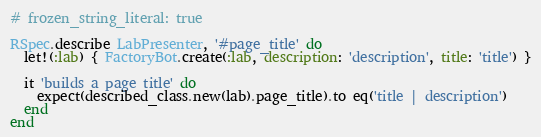<code> <loc_0><loc_0><loc_500><loc_500><_Ruby_># frozen_string_literal: true

RSpec.describe LabPresenter, '#page_title' do
  let!(:lab) { FactoryBot.create(:lab, description: 'description', title: 'title') }

  it 'builds a page title' do
    expect(described_class.new(lab).page_title).to eq('title | description')
  end
end
</code> 